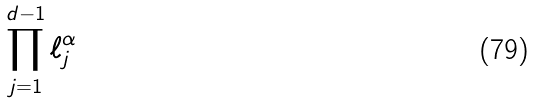Convert formula to latex. <formula><loc_0><loc_0><loc_500><loc_500>\prod _ { j = 1 } ^ { d - 1 } \ell _ { j } ^ { \alpha }</formula> 